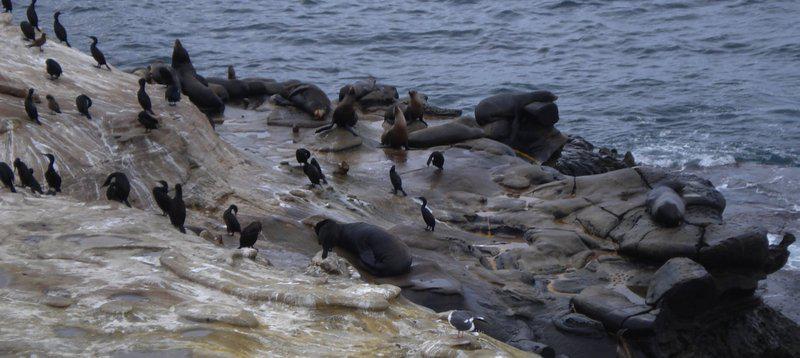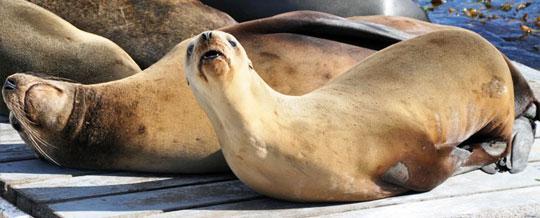The first image is the image on the left, the second image is the image on the right. Evaluate the accuracy of this statement regarding the images: "An image shows multiple seals lying on a plank-look manmade structure.". Is it true? Answer yes or no. Yes. 